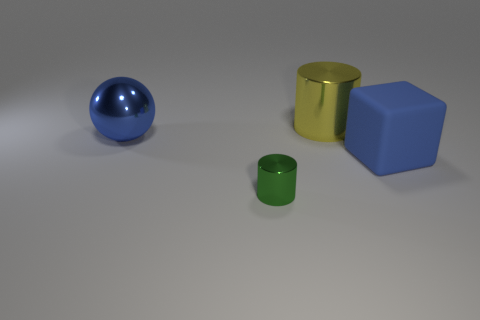Add 3 tiny shiny cylinders. How many objects exist? 7 Subtract all balls. How many objects are left? 3 Add 3 yellow objects. How many yellow objects are left? 4 Add 1 brown rubber cubes. How many brown rubber cubes exist? 1 Subtract 0 blue cylinders. How many objects are left? 4 Subtract all yellow cylinders. Subtract all large metal cylinders. How many objects are left? 2 